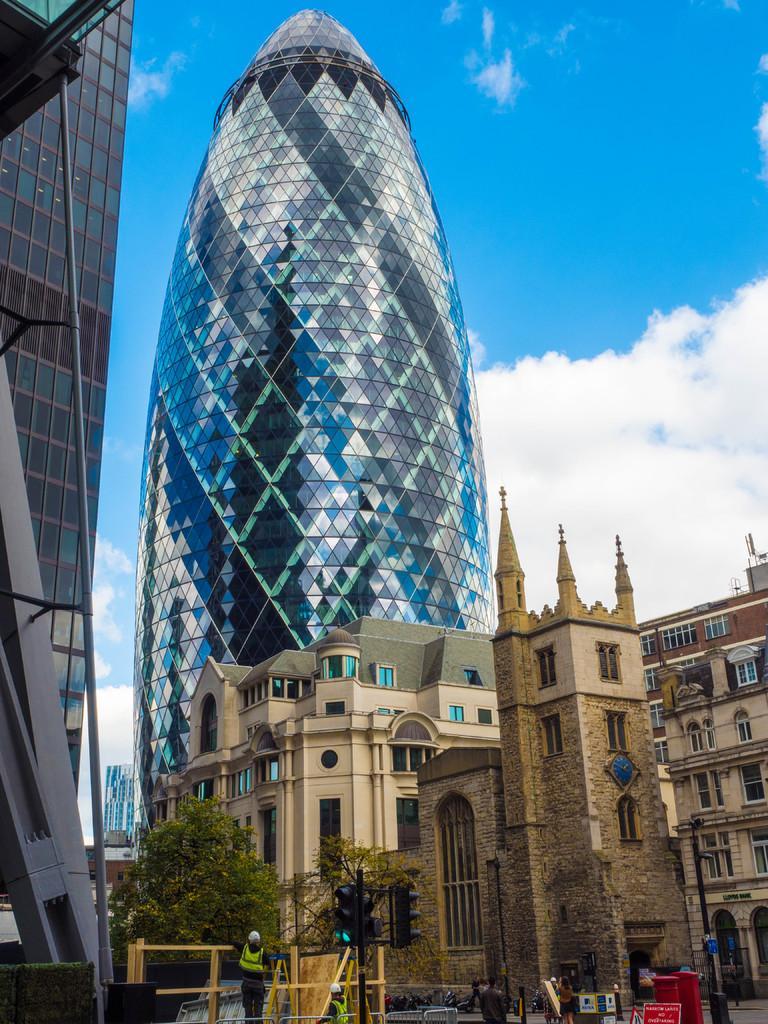In one or two sentences, can you explain what this image depicts? At the center of the image there are some buildings, in front of the building there is a road. On the road there are a few people standing and some sign boards, signal and trees. In the background there is a sky. 